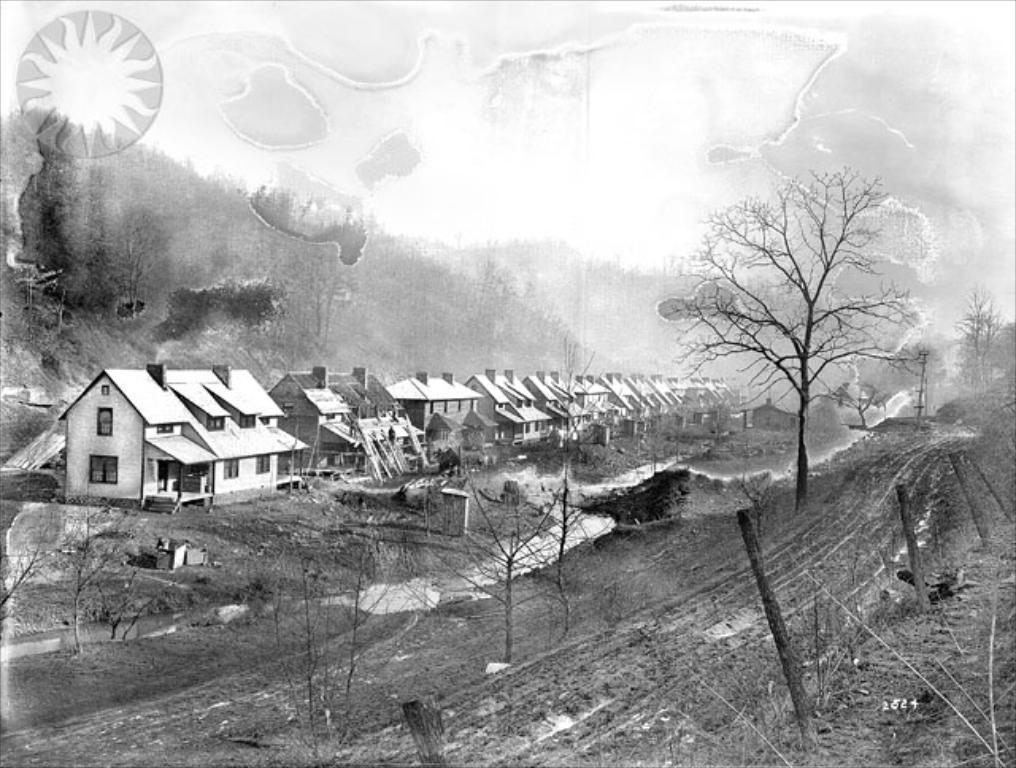How would you summarize this image in a sentence or two? There are few buildings in the left corner and there are few dried trees and a fence in the right corner and there are trees in the background. 